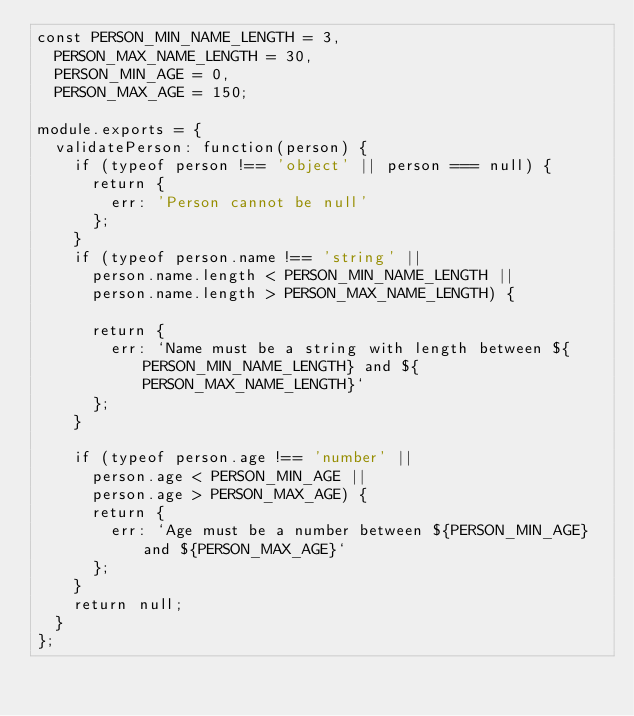Convert code to text. <code><loc_0><loc_0><loc_500><loc_500><_JavaScript_>const PERSON_MIN_NAME_LENGTH = 3,
  PERSON_MAX_NAME_LENGTH = 30,
  PERSON_MIN_AGE = 0,
  PERSON_MAX_AGE = 150;

module.exports = {
  validatePerson: function(person) {
    if (typeof person !== 'object' || person === null) {
      return {
        err: 'Person cannot be null'
      };
    }
    if (typeof person.name !== 'string' ||
      person.name.length < PERSON_MIN_NAME_LENGTH ||
      person.name.length > PERSON_MAX_NAME_LENGTH) {

      return {
        err: `Name must be a string with length between ${PERSON_MIN_NAME_LENGTH} and ${PERSON_MAX_NAME_LENGTH}`
      };
    }

    if (typeof person.age !== 'number' ||
      person.age < PERSON_MIN_AGE ||
      person.age > PERSON_MAX_AGE) {
      return {
        err: `Age must be a number between ${PERSON_MIN_AGE} and ${PERSON_MAX_AGE}`
      };
    }
    return null;
  }
};
</code> 